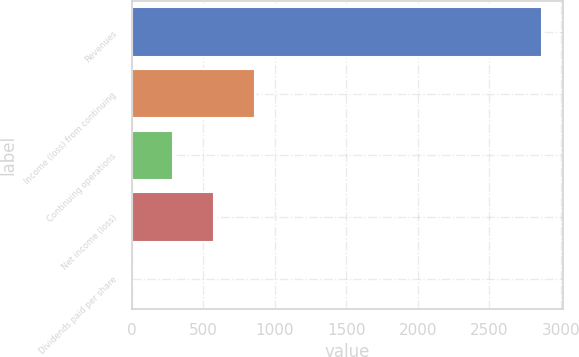<chart> <loc_0><loc_0><loc_500><loc_500><bar_chart><fcel>Revenues<fcel>Income (loss) from continuing<fcel>Continuing operations<fcel>Net income (loss)<fcel>Dividends paid per share<nl><fcel>2870<fcel>861.15<fcel>287.19<fcel>574.17<fcel>0.21<nl></chart> 